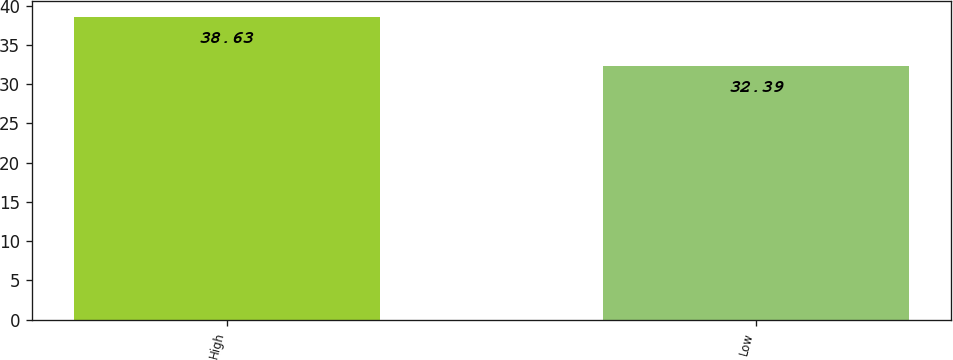<chart> <loc_0><loc_0><loc_500><loc_500><bar_chart><fcel>High<fcel>Low<nl><fcel>38.63<fcel>32.39<nl></chart> 